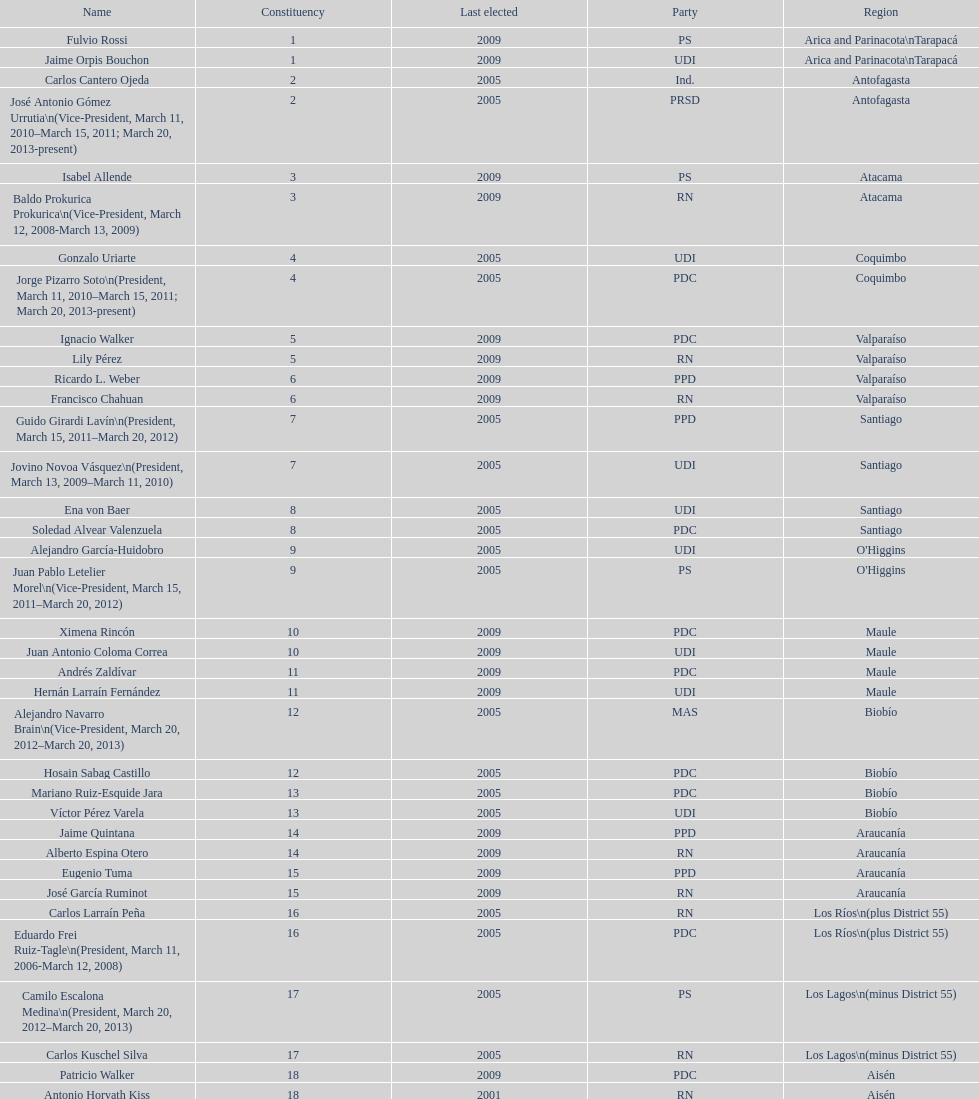How many total consituency are listed in the table? 19. 